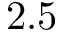<formula> <loc_0><loc_0><loc_500><loc_500>2 . 5</formula> 